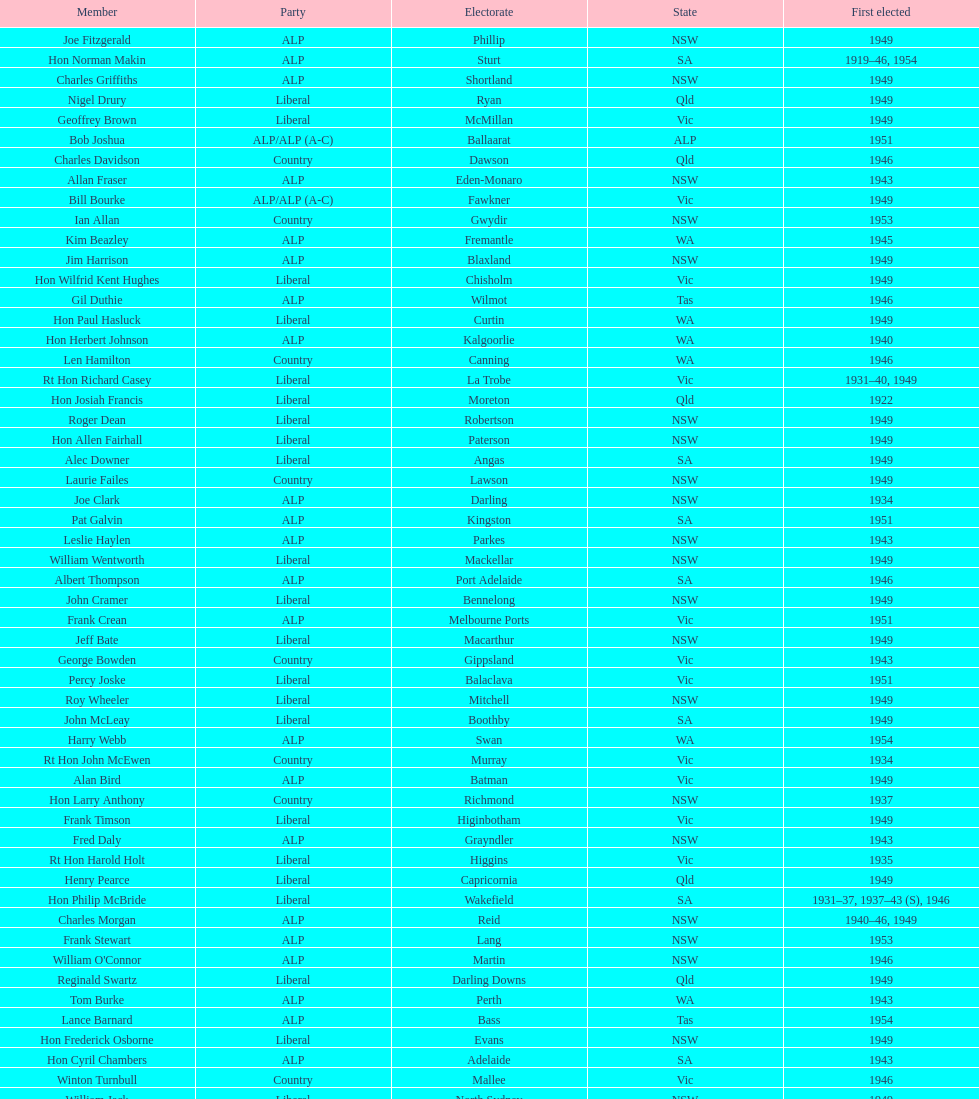Who was the first member to be elected? Charles Adermann. 